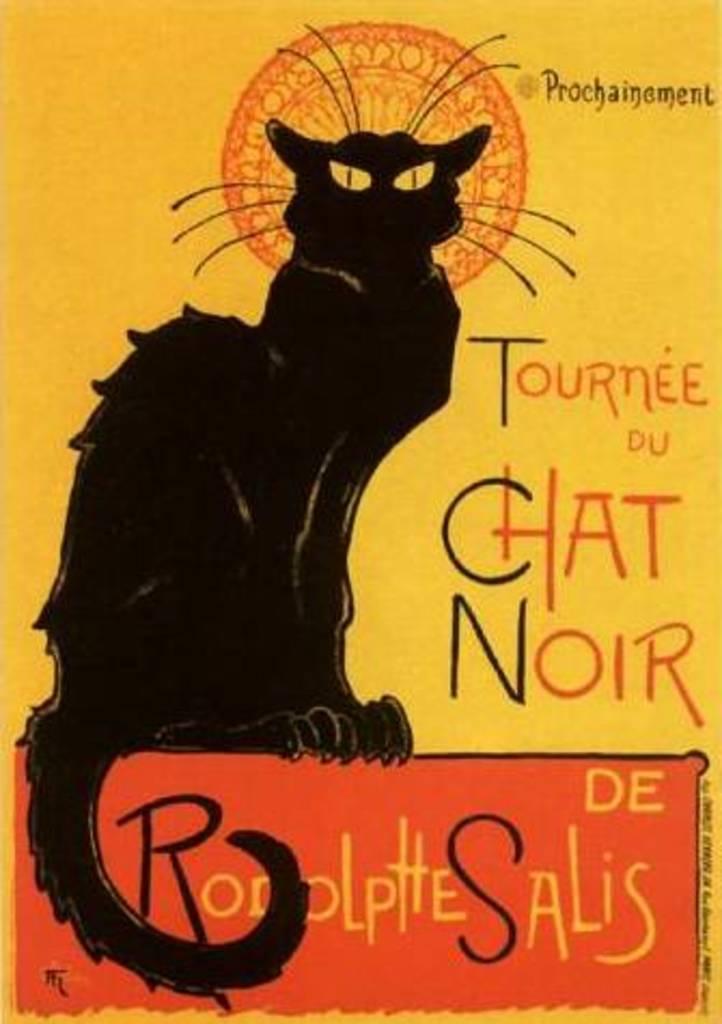Can you describe this image briefly? In this picture we can see a poster, on which we can see a black cat and some text. 